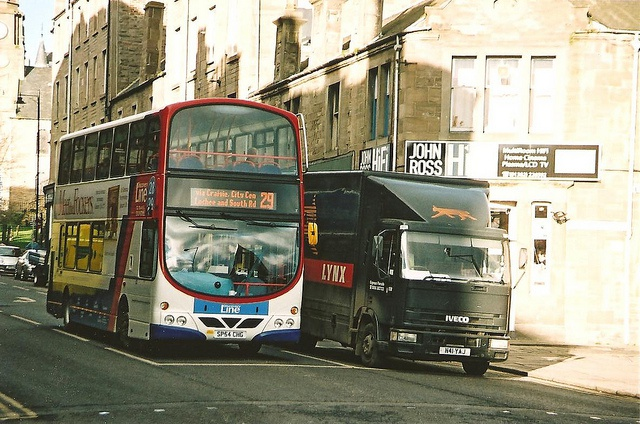Describe the objects in this image and their specific colors. I can see bus in beige, black, gray, darkgray, and ivory tones, truck in beige, black, gray, darkgray, and ivory tones, car in beige, black, ivory, gray, and darkgray tones, and car in beige, black, ivory, gray, and darkgray tones in this image. 